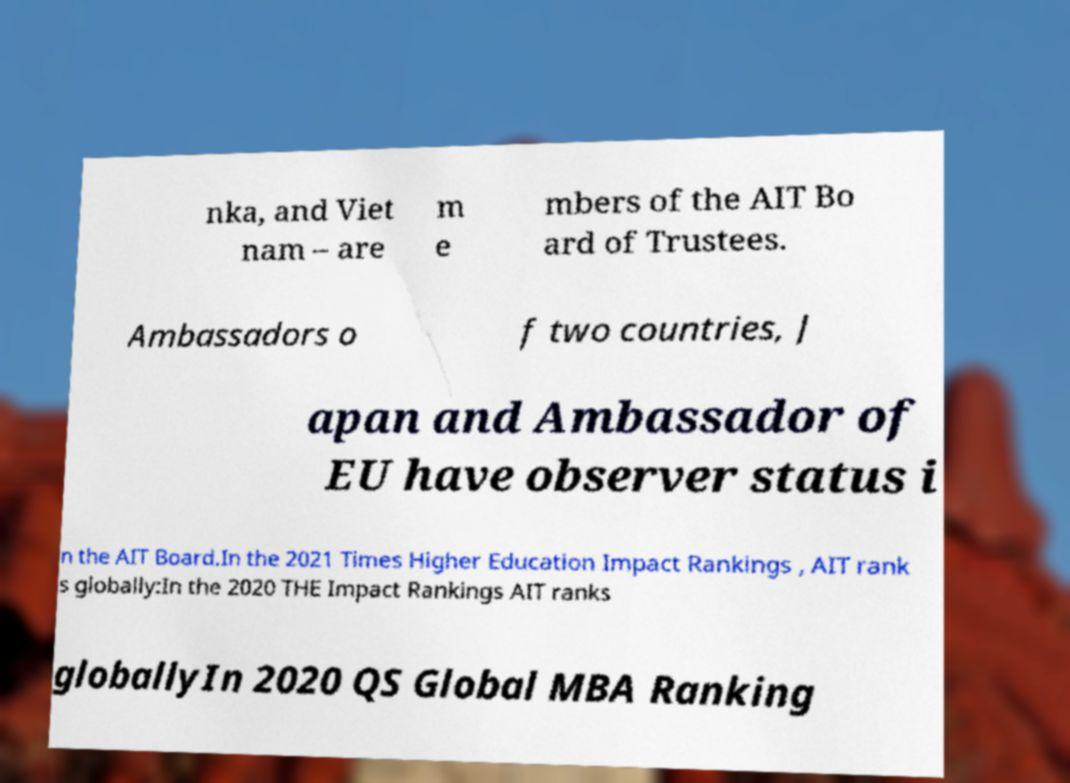Can you read and provide the text displayed in the image?This photo seems to have some interesting text. Can you extract and type it out for me? nka, and Viet nam – are m e mbers of the AIT Bo ard of Trustees. Ambassadors o f two countries, J apan and Ambassador of EU have observer status i n the AIT Board.In the 2021 Times Higher Education Impact Rankings , AIT rank s globally:In the 2020 THE Impact Rankings AIT ranks globallyIn 2020 QS Global MBA Ranking 